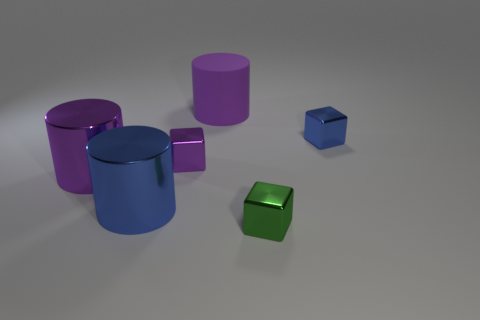Add 3 purple metallic objects. How many objects exist? 9 Subtract all purple cylinders. Subtract all big matte cylinders. How many objects are left? 3 Add 5 purple matte objects. How many purple matte objects are left? 6 Add 5 purple rubber cylinders. How many purple rubber cylinders exist? 6 Subtract 1 purple cylinders. How many objects are left? 5 